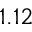Convert formula to latex. <formula><loc_0><loc_0><loc_500><loc_500>1 . 1 2</formula> 